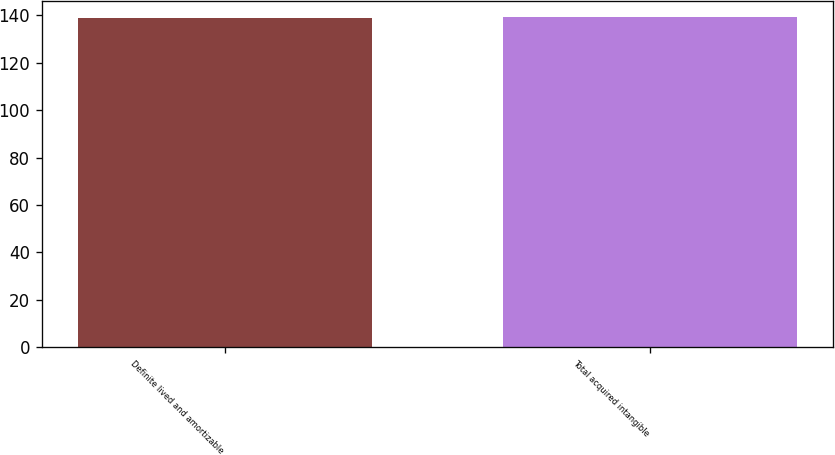<chart> <loc_0><loc_0><loc_500><loc_500><bar_chart><fcel>Definite lived and amortizable<fcel>Total acquired intangible<nl><fcel>139<fcel>139.1<nl></chart> 